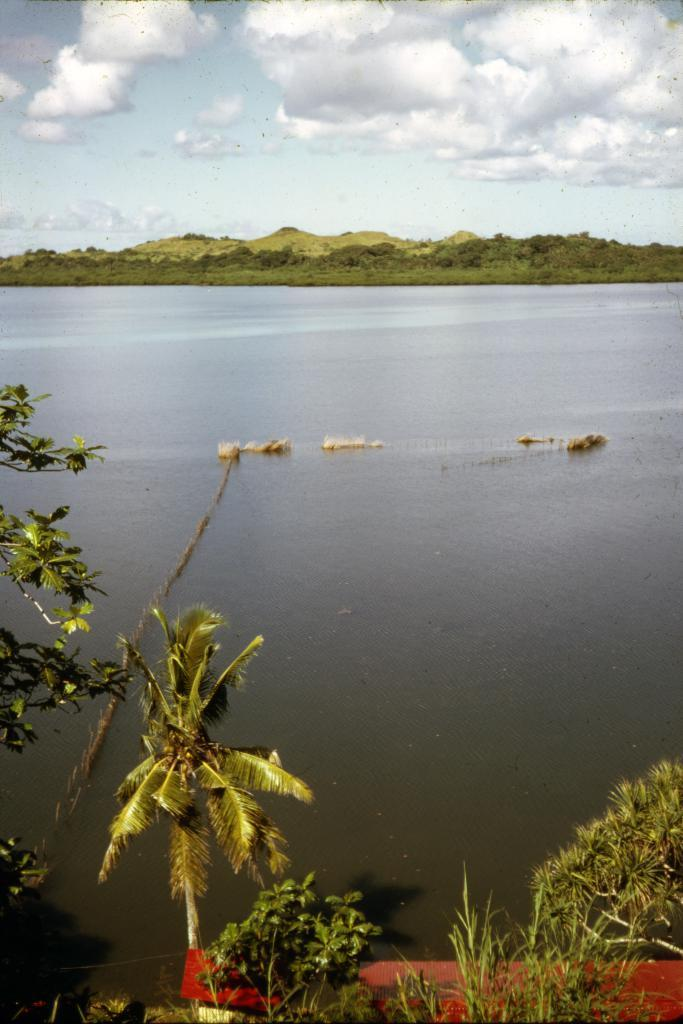What type of vegetation can be seen in the image? There are trees in the image. What else can be seen besides trees? There is water and grass visible in the image. How would you describe the sky in the image? The sky is cloudy in the image. What act of destruction is depicted in the image? There is no act of destruction depicted in the image; it features trees, water, grass, and a cloudy sky. What type of plant is shown growing in the water in the image? There are no plants growing in the water in the image. 